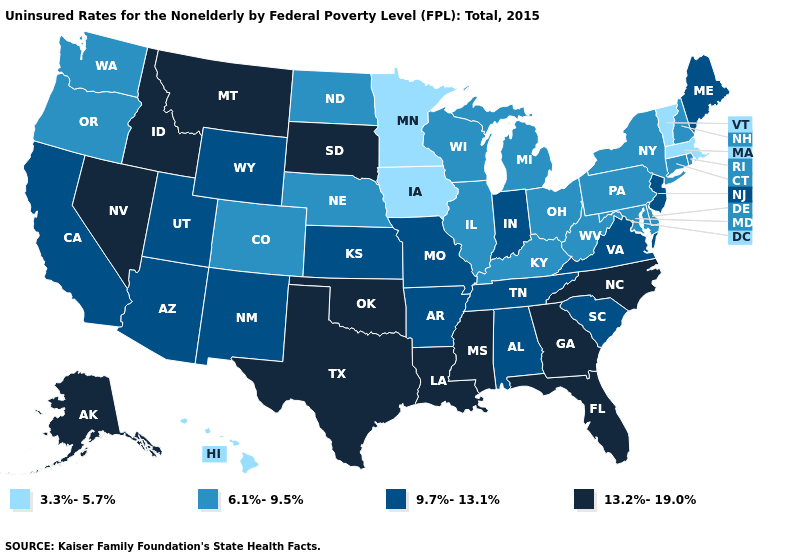What is the value of New Mexico?
Concise answer only. 9.7%-13.1%. What is the lowest value in the MidWest?
Answer briefly. 3.3%-5.7%. Name the states that have a value in the range 13.2%-19.0%?
Quick response, please. Alaska, Florida, Georgia, Idaho, Louisiana, Mississippi, Montana, Nevada, North Carolina, Oklahoma, South Dakota, Texas. Name the states that have a value in the range 3.3%-5.7%?
Write a very short answer. Hawaii, Iowa, Massachusetts, Minnesota, Vermont. What is the value of Nevada?
Quick response, please. 13.2%-19.0%. Does the first symbol in the legend represent the smallest category?
Be succinct. Yes. Does Minnesota have the lowest value in the MidWest?
Concise answer only. Yes. Does Arkansas have the highest value in the South?
Give a very brief answer. No. What is the value of New York?
Write a very short answer. 6.1%-9.5%. Name the states that have a value in the range 3.3%-5.7%?
Short answer required. Hawaii, Iowa, Massachusetts, Minnesota, Vermont. Does Nebraska have a higher value than Massachusetts?
Keep it brief. Yes. Does California have the highest value in the USA?
Quick response, please. No. Among the states that border Alabama , which have the lowest value?
Quick response, please. Tennessee. Name the states that have a value in the range 13.2%-19.0%?
Give a very brief answer. Alaska, Florida, Georgia, Idaho, Louisiana, Mississippi, Montana, Nevada, North Carolina, Oklahoma, South Dakota, Texas. Does Indiana have a higher value than Utah?
Give a very brief answer. No. 